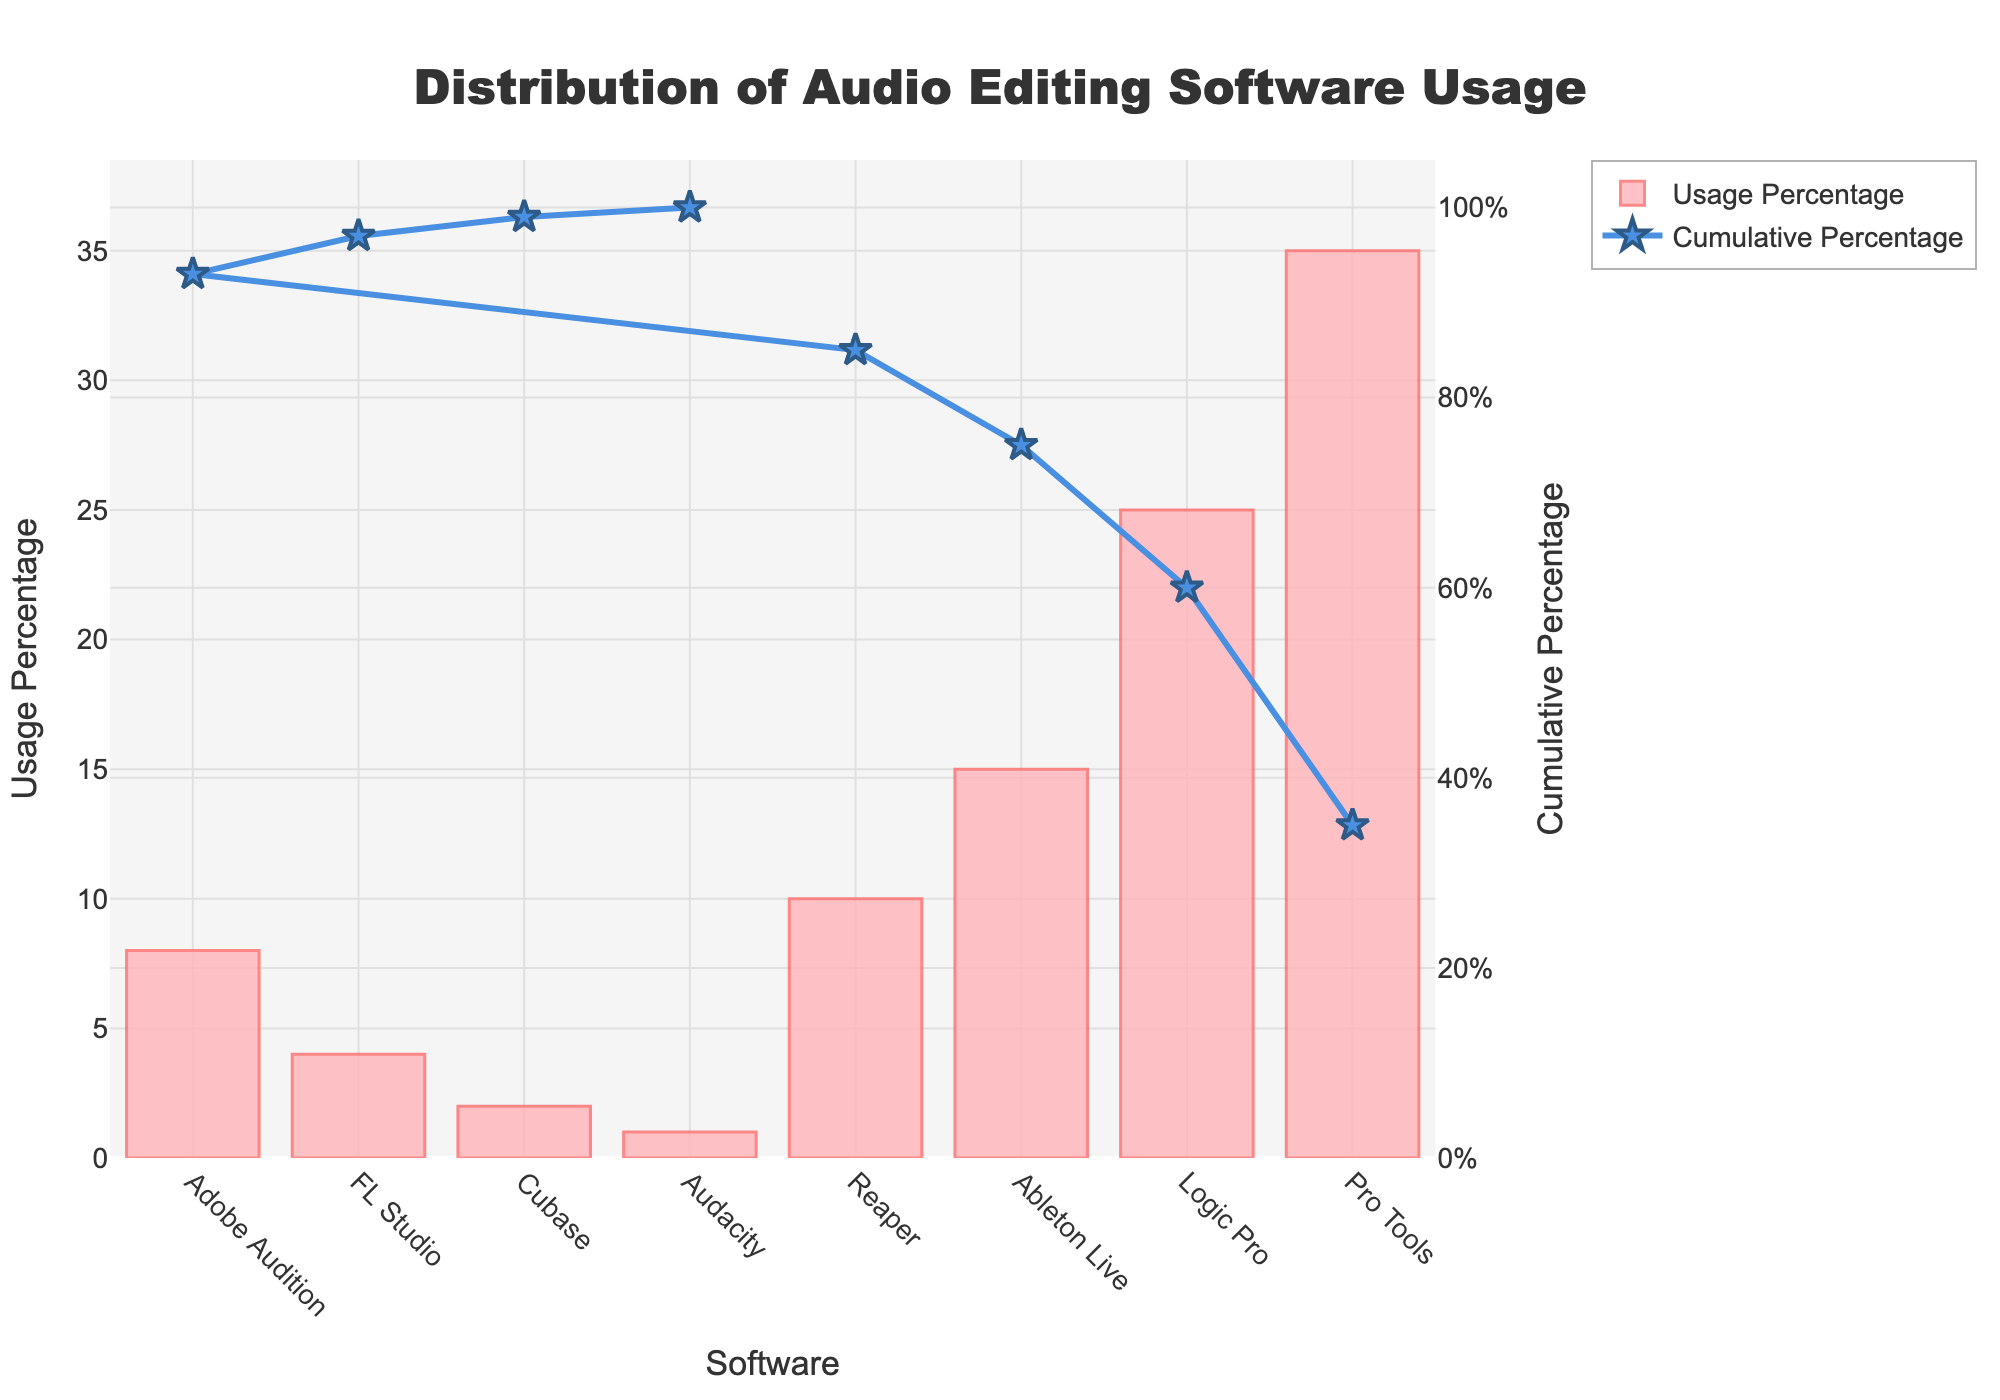What's the title of the figure? The title of the figure is usually found at the top of the chart, and it provides a summary of what the chart is about. In this figure, the title reads "Distribution of Audio Editing Software Usage".
Answer: Distribution of Audio Editing Software Usage What software has the highest usage percentage? Looking at the bar heights, the highest bar represents the software with the highest usage percentage. Pro Tools has the tallest bar.
Answer: Pro Tools Which software has the lowest usage percentage? The shortest bar in the chart indicates the software with the lowest usage. In this case, Audacity has the shortest bar.
Answer: Audacity What is the cumulative percentage for Logic Pro? The cumulative percentage line shows how much of the total usage percentage is covered up to each software. The marker on the line for Logic Pro corresponds to the cumulative percentage. It is approximately 60%.
Answer: 60% How many software options have a usage percentage above 10%? To answer this, count the bars that are taller than the line corresponding to 10%. Pro Tools, Logic Pro, Ableton Live, and Reaper all have usage percentages above 10%.
Answer: 4 What is the total usage percentage of the three least-used software? The three least-used software are Audacity, Cubase, and FL Studio. Their respective usage percentages are 1%, 2%, and 4%. Summing these: 1% + 2% + 4% = 7%.
Answer: 7% Which software usage accounts for exactly 10%? Identify the bar that corresponds to exactly 10% usage. Here, the bar for Reaper is labeled at 10%.
Answer: Reaper What is the visual marker used for the cumulative percentage line? The cumulative percentage line is marked with star symbols at each software point.
Answer: Stars What color is the bar representing Adobe Audition? Each bar has a color. For Adobe Audition, the bar color is light pink (variations of light red-pink).
Answer: Light pink Which software's usage makes up cumulatively over half of the total usage? To determine this, look at the cumulative percentage line where it crosses 50%. Pro Tools and Logic Pro together make up more than half of the total usage.
Answer: Pro Tools and Logic Pro 